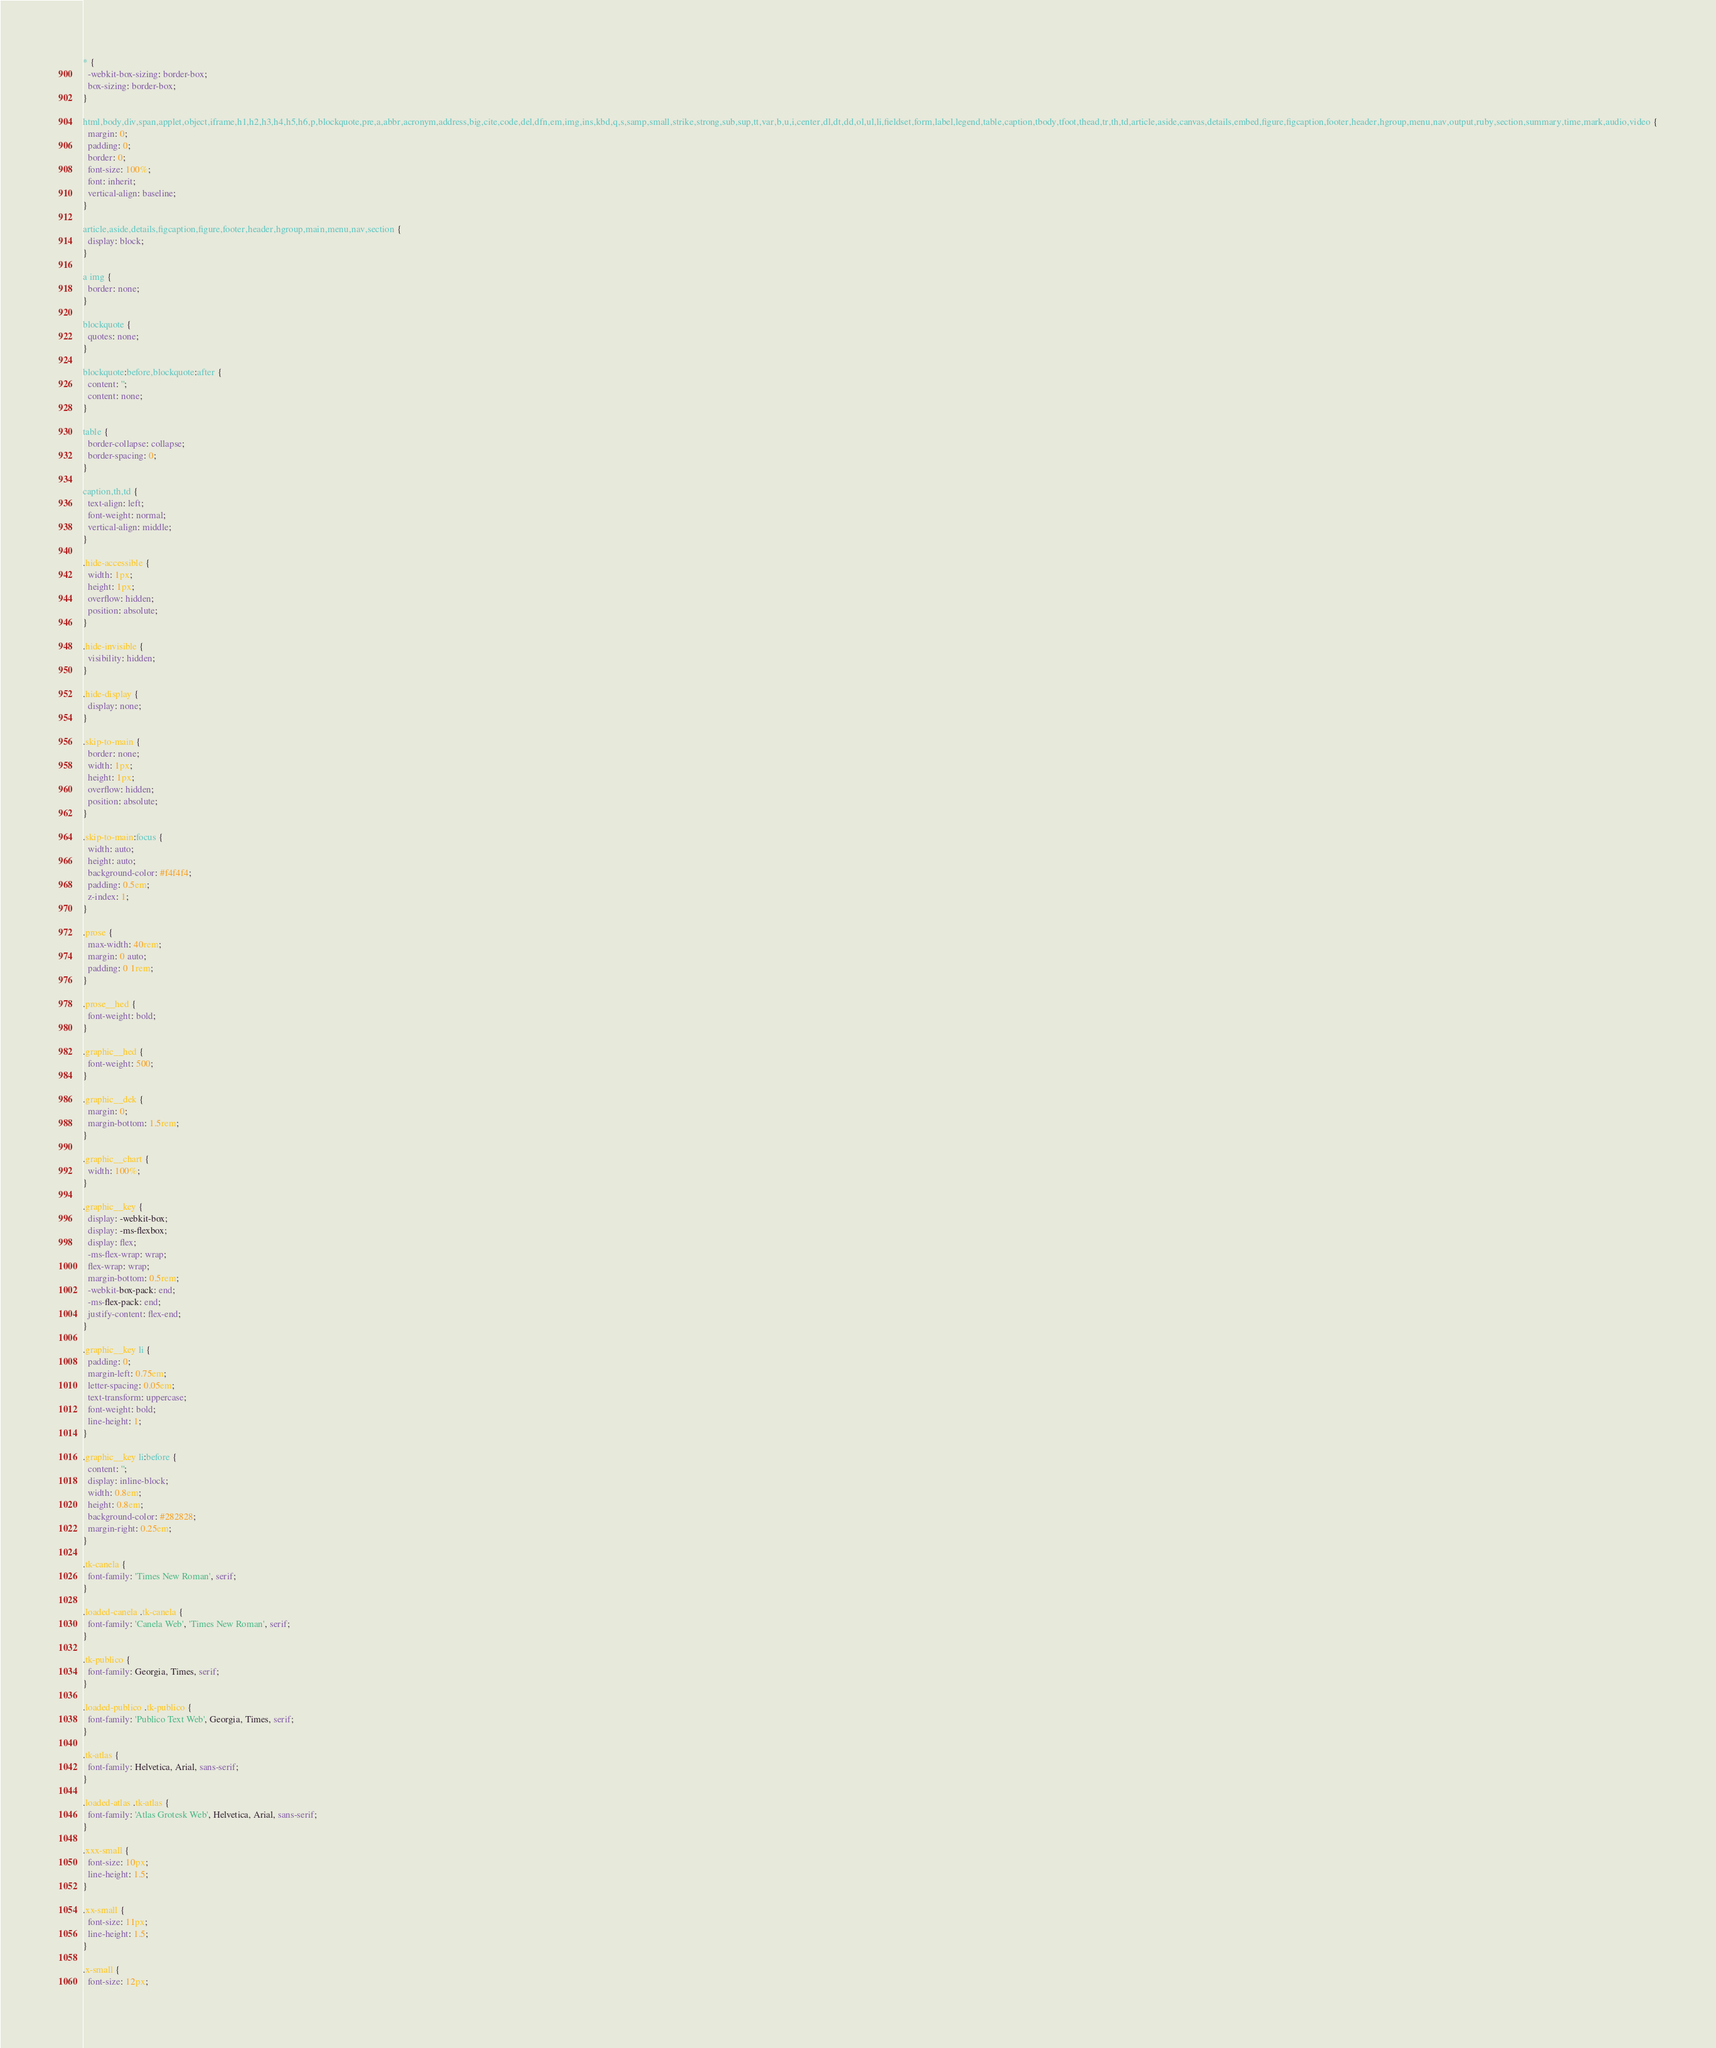Convert code to text. <code><loc_0><loc_0><loc_500><loc_500><_CSS_>* {
  -webkit-box-sizing: border-box;
  box-sizing: border-box;
}

html,body,div,span,applet,object,iframe,h1,h2,h3,h4,h5,h6,p,blockquote,pre,a,abbr,acronym,address,big,cite,code,del,dfn,em,img,ins,kbd,q,s,samp,small,strike,strong,sub,sup,tt,var,b,u,i,center,dl,dt,dd,ol,ul,li,fieldset,form,label,legend,table,caption,tbody,tfoot,thead,tr,th,td,article,aside,canvas,details,embed,figure,figcaption,footer,header,hgroup,menu,nav,output,ruby,section,summary,time,mark,audio,video {
  margin: 0;
  padding: 0;
  border: 0;
  font-size: 100%;
  font: inherit;
  vertical-align: baseline;
}

article,aside,details,figcaption,figure,footer,header,hgroup,main,menu,nav,section {
  display: block;
}

a img {
  border: none;
}

blockquote {
  quotes: none;
}

blockquote:before,blockquote:after {
  content: '';
  content: none;
}

table {
  border-collapse: collapse;
  border-spacing: 0;
}

caption,th,td {
  text-align: left;
  font-weight: normal;
  vertical-align: middle;
}

.hide-accessible {
  width: 1px;
  height: 1px;
  overflow: hidden;
  position: absolute;
}

.hide-invisible {
  visibility: hidden;
}

.hide-display {
  display: none;
}

.skip-to-main {
  border: none;
  width: 1px;
  height: 1px;
  overflow: hidden;
  position: absolute;
}

.skip-to-main:focus {
  width: auto;
  height: auto;
  background-color: #f4f4f4;
  padding: 0.5em;
  z-index: 1;
}

.prose {
  max-width: 40rem;
  margin: 0 auto;
  padding: 0 1rem;
}

.prose__hed {
  font-weight: bold;
}

.graphic__hed {
  font-weight: 500;
}

.graphic__dek {
  margin: 0;
  margin-bottom: 1.5rem;
}

.graphic__chart {
  width: 100%;
}

.graphic__key {
  display: -webkit-box;
  display: -ms-flexbox;
  display: flex;
  -ms-flex-wrap: wrap;
  flex-wrap: wrap;
  margin-bottom: 0.5rem;
  -webkit-box-pack: end;
  -ms-flex-pack: end;
  justify-content: flex-end;
}

.graphic__key li {
  padding: 0;
  margin-left: 0.75em;
  letter-spacing: 0.05em;
  text-transform: uppercase;
  font-weight: bold;
  line-height: 1;
}

.graphic__key li:before {
  content: '';
  display: inline-block;
  width: 0.8em;
  height: 0.8em;
  background-color: #282828;
  margin-right: 0.25em;
}

.tk-canela {
  font-family: 'Times New Roman', serif;
}

.loaded-canela .tk-canela {
  font-family: 'Canela Web', 'Times New Roman', serif;
}

.tk-publico {
  font-family: Georgia, Times, serif;
}

.loaded-publico .tk-publico {
  font-family: 'Publico Text Web', Georgia, Times, serif;
}

.tk-atlas {
  font-family: Helvetica, Arial, sans-serif;
}

.loaded-atlas .tk-atlas {
  font-family: 'Atlas Grotesk Web', Helvetica, Arial, sans-serif;
}

.xxx-small {
  font-size: 10px;
  line-height: 1.5;
}

.xx-small {
  font-size: 11px;
  line-height: 1.5;
}

.x-small {
  font-size: 12px;</code> 